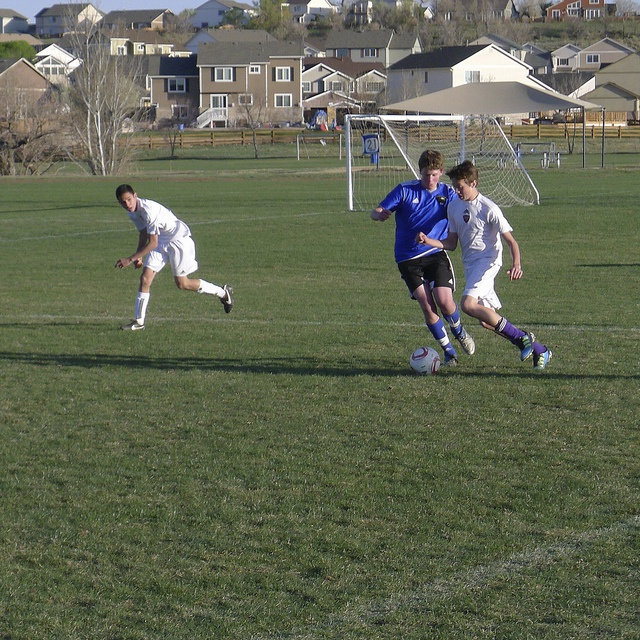Describe the objects in this image and their specific colors. I can see people in lightblue, black, navy, gray, and darkblue tones, people in lavender, gray, white, and black tones, people in lightblue, white, gray, darkgray, and black tones, and sports ball in lightblue, gray, and black tones in this image. 